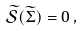<formula> <loc_0><loc_0><loc_500><loc_500>\widetilde { \mathcal { S } } ( \widetilde { \Sigma } ) = 0 \, ,</formula> 